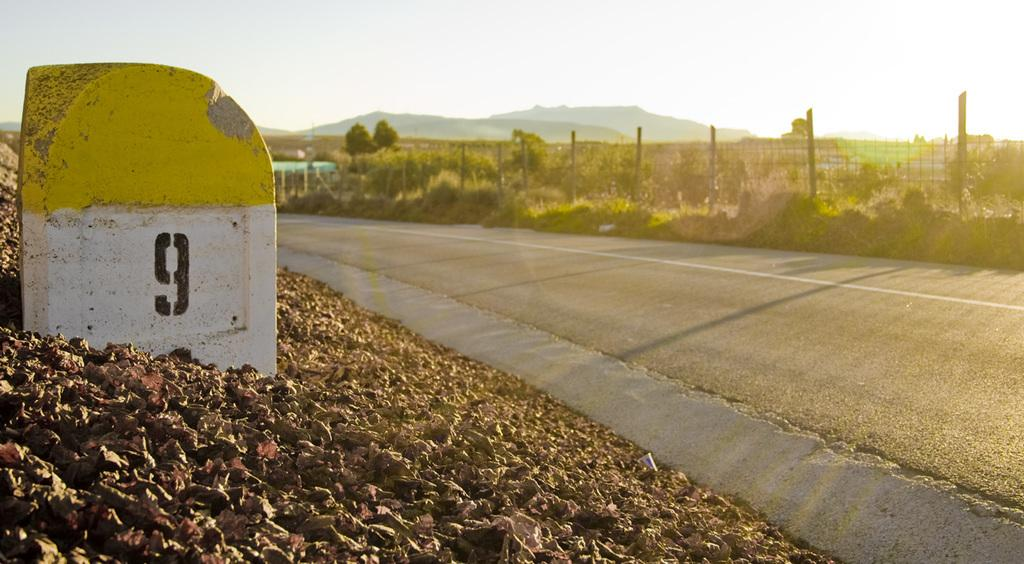What is the main feature of the image? There is a road in the image. What is located beside the road? There is a mile stone beside the road. What can be seen in the background of the image? There are trees visible in the distance. What type of barrier is present in the image? There is a fence in the image. What type of vegetation is present in the image? There are plants in the image. Where is the baby sitting with a notebook in the image? There is no baby or notebook present in the image. 